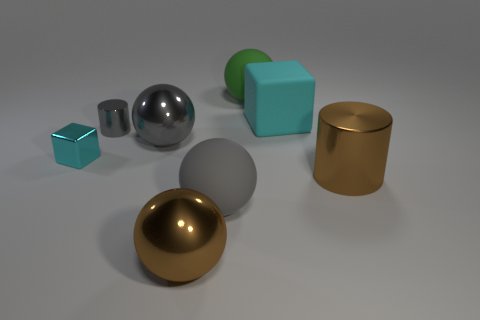Is there any other thing that has the same material as the big cyan cube?
Offer a very short reply. Yes. Are the cyan block that is to the left of the large gray rubber sphere and the large brown ball that is right of the gray cylinder made of the same material?
Your answer should be compact. Yes. How big is the shiny cylinder on the right side of the gray rubber thing that is in front of the large cyan rubber object?
Provide a succinct answer. Large. Are there any large cylinders that have the same color as the tiny cylinder?
Offer a terse response. No. There is a metal ball that is behind the small cyan block; is it the same color as the big rubber sphere to the left of the green ball?
Your response must be concise. Yes. What shape is the large cyan rubber object?
Provide a succinct answer. Cube. There is a gray rubber sphere; how many large gray metallic balls are on the right side of it?
Your answer should be very brief. 0. How many gray objects are the same material as the large cyan block?
Keep it short and to the point. 1. Does the large brown thing that is on the right side of the gray rubber thing have the same material as the tiny cyan cube?
Your response must be concise. Yes. Are there any big gray things?
Make the answer very short. Yes. 